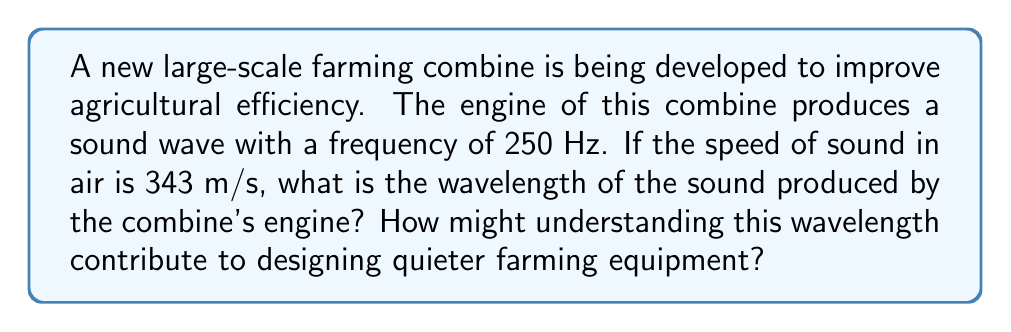Can you answer this question? To solve this problem, we'll use the wave equation that relates wave speed, frequency, and wavelength:

$$v = f\lambda$$

Where:
$v$ = wave speed (m/s)
$f$ = frequency (Hz)
$\lambda$ = wavelength (m)

Given:
$v = 343$ m/s (speed of sound in air)
$f = 250$ Hz (frequency of the sound wave)

Step 1: Rearrange the wave equation to solve for wavelength:
$$\lambda = \frac{v}{f}$$

Step 2: Substitute the known values:
$$\lambda = \frac{343 \text{ m/s}}{250 \text{ Hz}}$$

Step 3: Calculate the wavelength:
$$\lambda = 1.372 \text{ m}$$

Understanding this wavelength can contribute to designing quieter farming equipment in several ways:

1. Sound absorption: Materials can be designed to absorb sound waves with this specific wavelength, reducing noise pollution.

2. Acoustic enclosures: The size and shape of engine enclosures can be optimized to reflect or absorb sound waves of this wavelength.

3. Active noise control: Systems can be developed to produce sound waves that are out of phase with the engine noise, effectively canceling it out.

4. Equipment spacing: The layout of multiple pieces of equipment can be designed to minimize constructive interference of sound waves.

5. Regulatory compliance: Knowing the wavelength helps in ensuring the equipment meets noise emission standards for agricultural machinery.
Answer: 1.372 m 